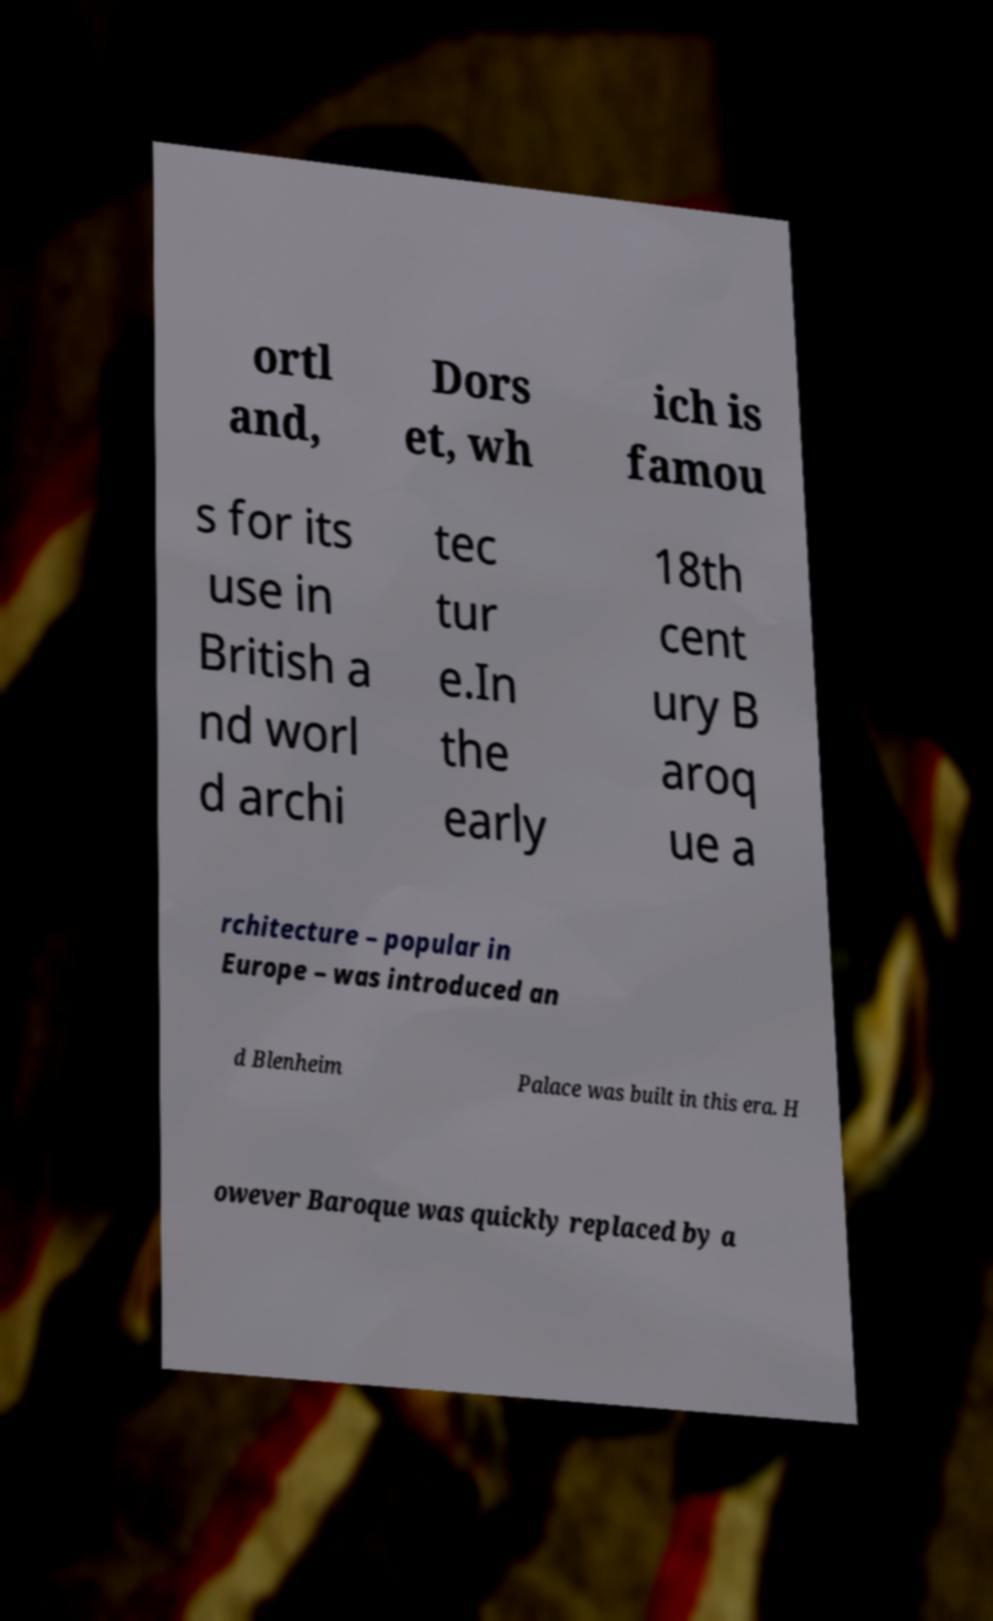There's text embedded in this image that I need extracted. Can you transcribe it verbatim? ortl and, Dors et, wh ich is famou s for its use in British a nd worl d archi tec tur e.In the early 18th cent ury B aroq ue a rchitecture – popular in Europe – was introduced an d Blenheim Palace was built in this era. H owever Baroque was quickly replaced by a 